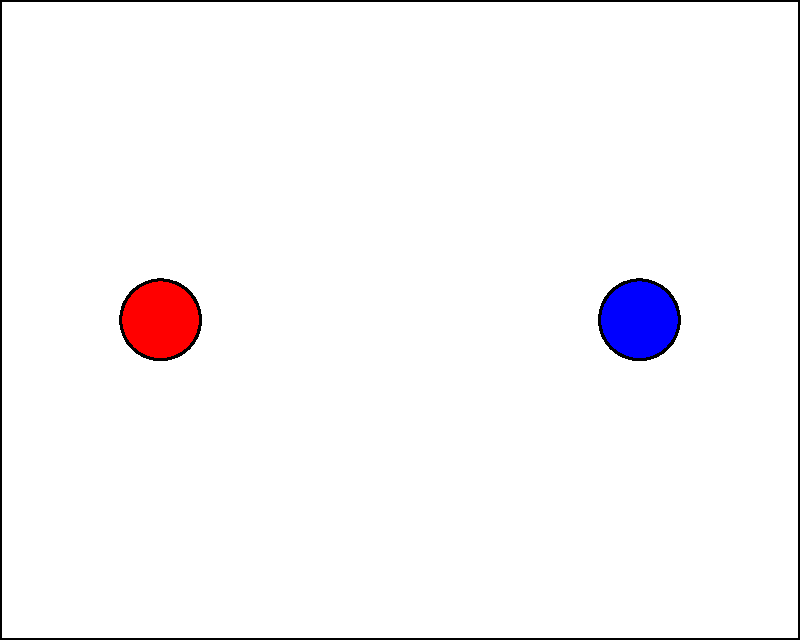As a Broadway producer aiming to impress critics, you're reviewing a stage layout design for your upcoming show. The stage measures 100 ft wide by 80 ft deep. Four key props are placed as follows:
A: Red circular prop at (20,40)
B: Blue circular prop at (80,40)
C: Green rectangular prop centered at (50,20)
D: Yellow elliptical prop at (50,70)

What is the total distance (in feet) between props A and B, and between props C and D? To solve this problem, we need to calculate two distances and sum them up:

1. Distance between props A and B:
   - A is at (20,40) and B is at (80,40)
   - They have the same y-coordinate, so we only need to consider the x-coordinates
   - Distance = 80 - 20 = 60 ft

2. Distance between props C and D:
   - C is centered at (50,20) and D is at (50,70)
   - They have the same x-coordinate, so we only need to consider the y-coordinates
   - Distance = 70 - 20 = 50 ft

3. Total distance:
   - Sum of the two distances = 60 ft + 50 ft = 110 ft

Therefore, the total distance between props A and B, and between props C and D is 110 ft.
Answer: 110 ft 